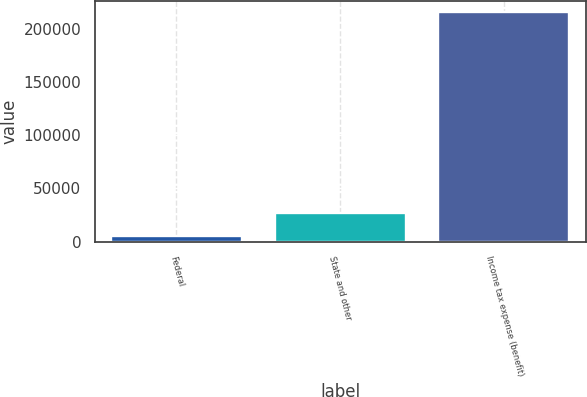<chart> <loc_0><loc_0><loc_500><loc_500><bar_chart><fcel>Federal<fcel>State and other<fcel>Income tax expense (benefit)<nl><fcel>5619<fcel>26599.1<fcel>215420<nl></chart> 